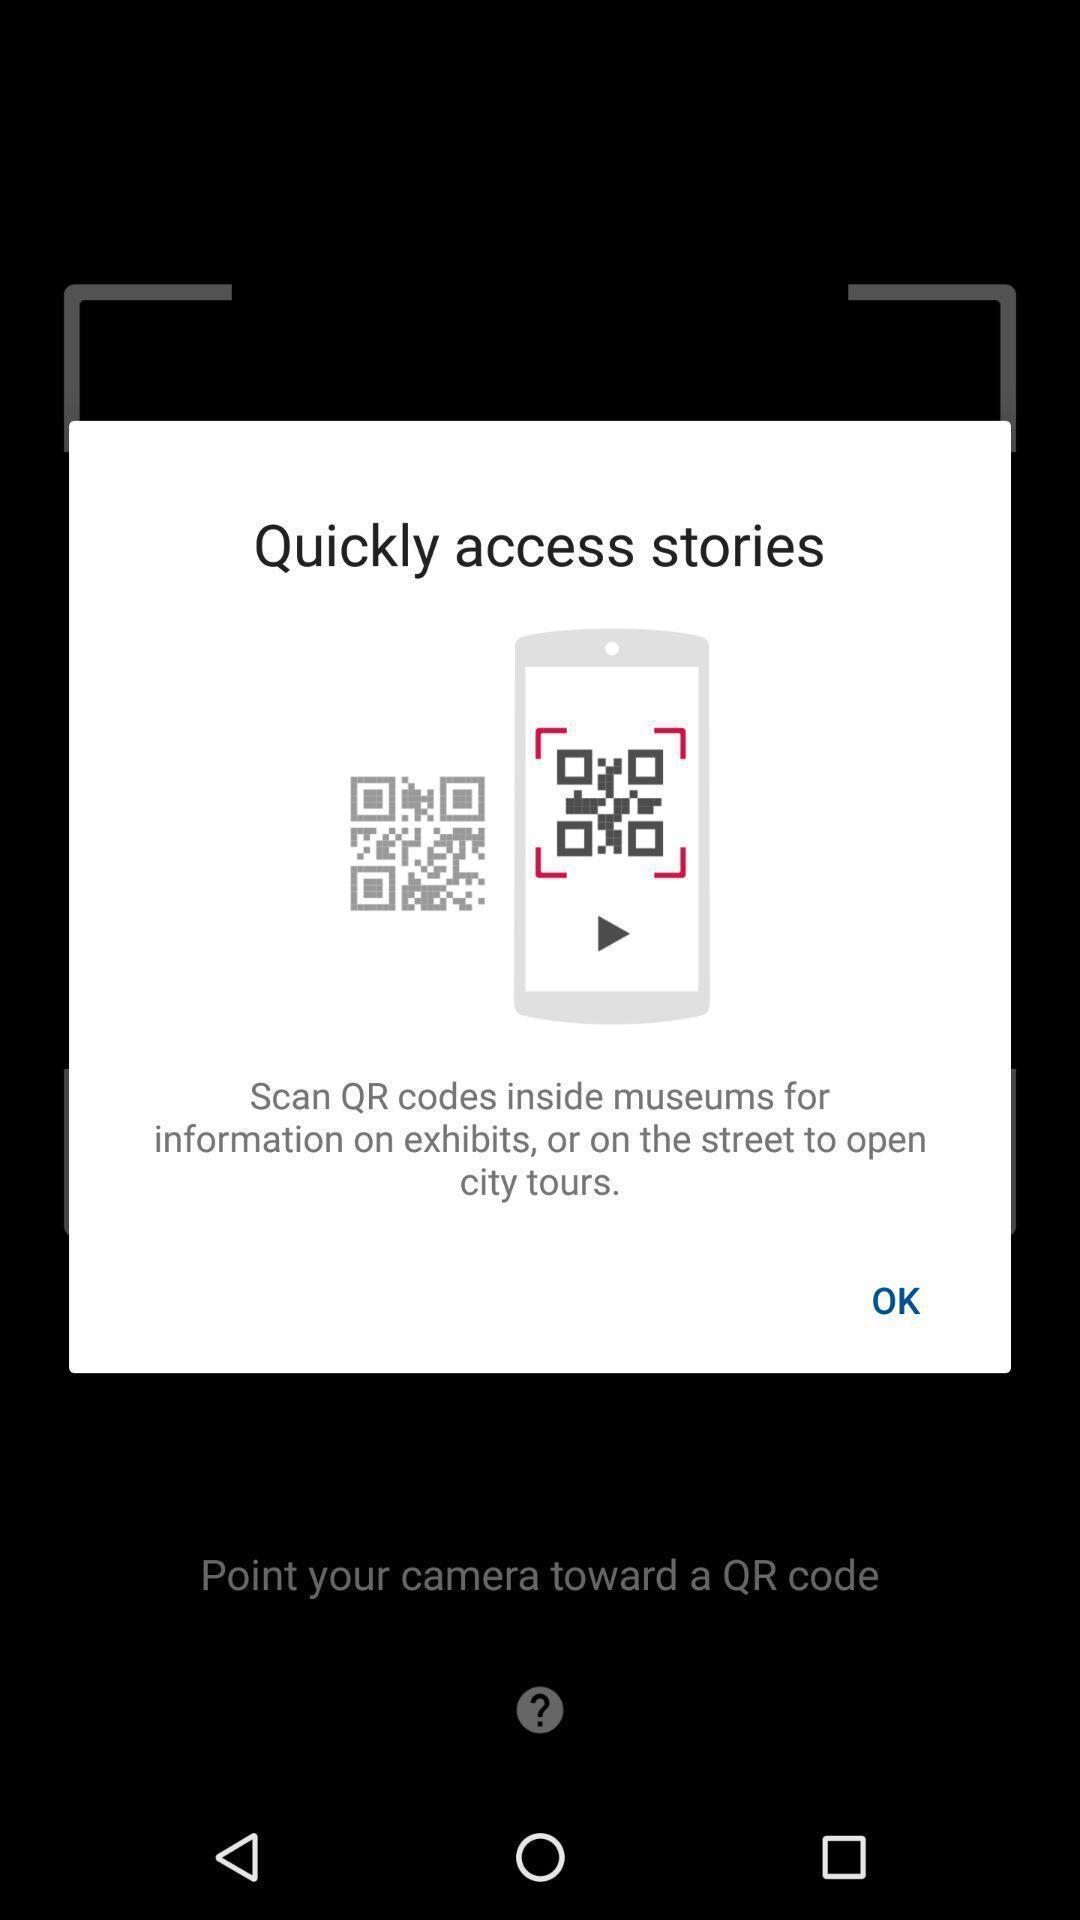Tell me what you see in this picture. Screen displaying about scanning a qr code. 